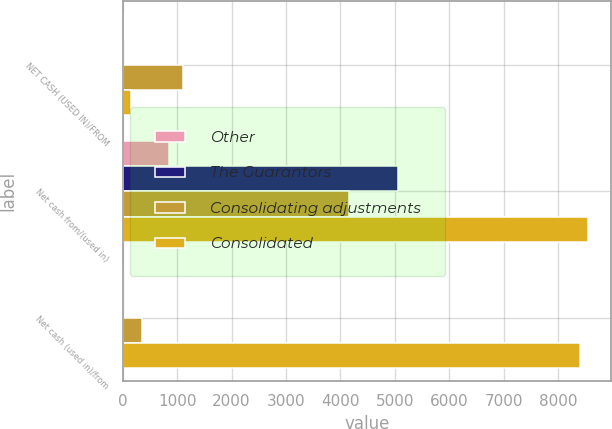<chart> <loc_0><loc_0><loc_500><loc_500><stacked_bar_chart><ecel><fcel>NET CASH (USED IN)/FROM<fcel>Net cash from/(used in)<fcel>Net cash (used in)/from<nl><fcel>Other<fcel>20<fcel>849<fcel>3<nl><fcel>The Guarantors<fcel>4<fcel>5054<fcel>2<nl><fcel>Consolidating adjustments<fcel>1101<fcel>4153<fcel>358<nl><fcel>Consolidated<fcel>157<fcel>8553<fcel>8396<nl></chart> 